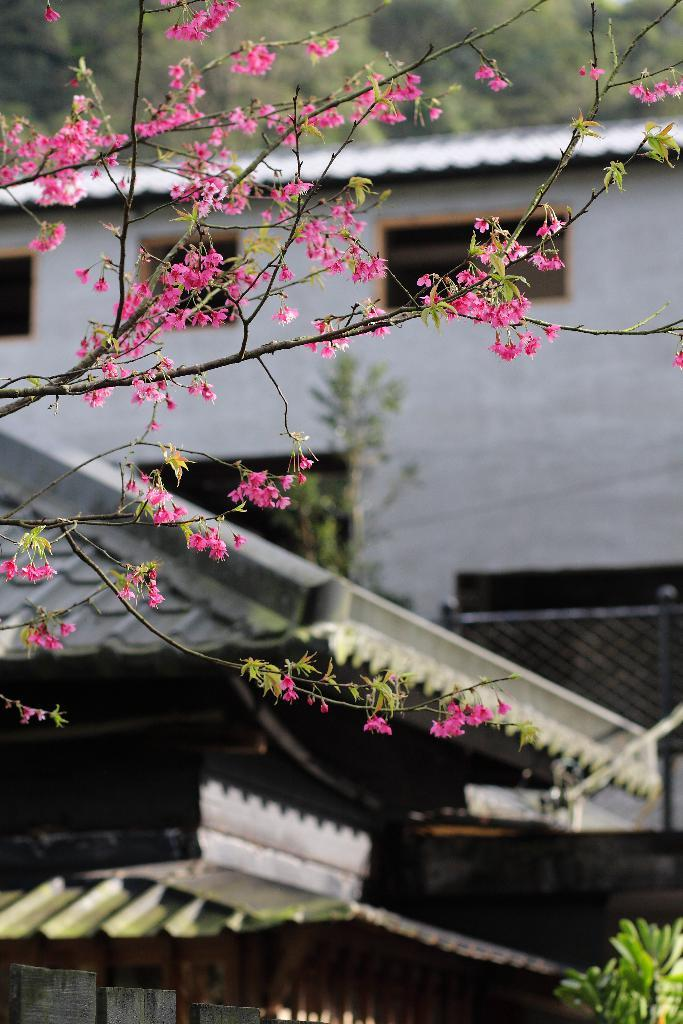What type of vegetation can be seen on the left side of the image? There are branches with leaves and flowers on the left side of the image. What type of structures are present on the ground in the image? There are buildings with roofs and windows on the ground in the image. How would you describe the background of the image? The background of the image is blurred. How many chairs are visible in the image? There are no chairs present in the image. What color is the shirt worn by the tree in the image? There is no tree wearing a shirt in the image; it is a natural object with branches, leaves, and flowers. 